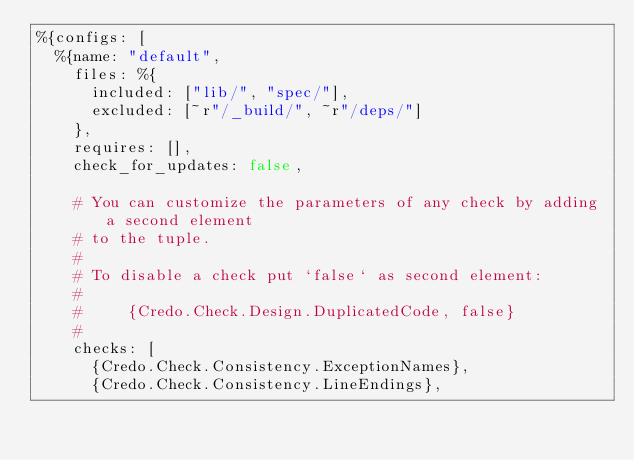Convert code to text. <code><loc_0><loc_0><loc_500><loc_500><_Elixir_>%{configs: [
  %{name: "default",
    files: %{
      included: ["lib/", "spec/"],
      excluded: [~r"/_build/", ~r"/deps/"]
    },
    requires: [],
    check_for_updates: false,

    # You can customize the parameters of any check by adding a second element
    # to the tuple.
    #
    # To disable a check put `false` as second element:
    #
    #     {Credo.Check.Design.DuplicatedCode, false}
    #
    checks: [
      {Credo.Check.Consistency.ExceptionNames},
      {Credo.Check.Consistency.LineEndings},</code> 